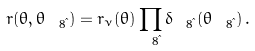Convert formula to latex. <formula><loc_0><loc_0><loc_500><loc_500>r ( \theta , \theta _ { \ 8 { \i } } ) = r _ { \nu } ( \theta ) \prod _ { \ 8 { \i } } \delta _ { \ 8 { \i } } ( \theta _ { \ 8 { \i } } ) \, .</formula> 